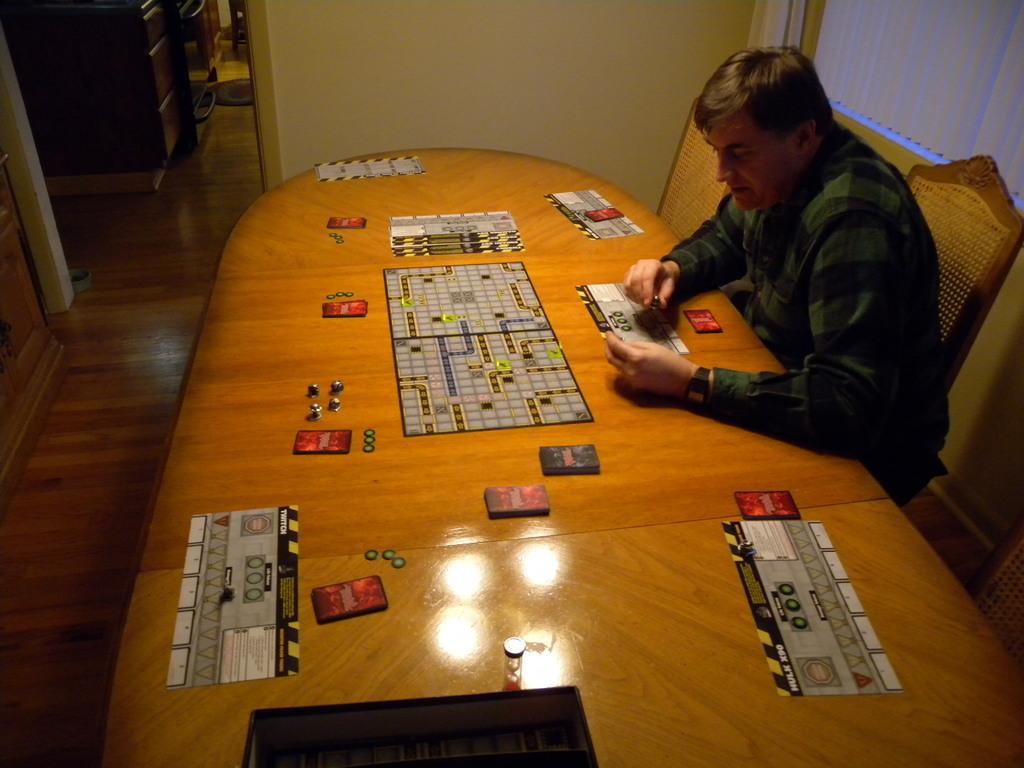How would you summarize this image in a sentence or two? There is a man sitting in front of a table and the chair, holding some cards in the hands. There is a game here. In the background we can observe a wall here. 